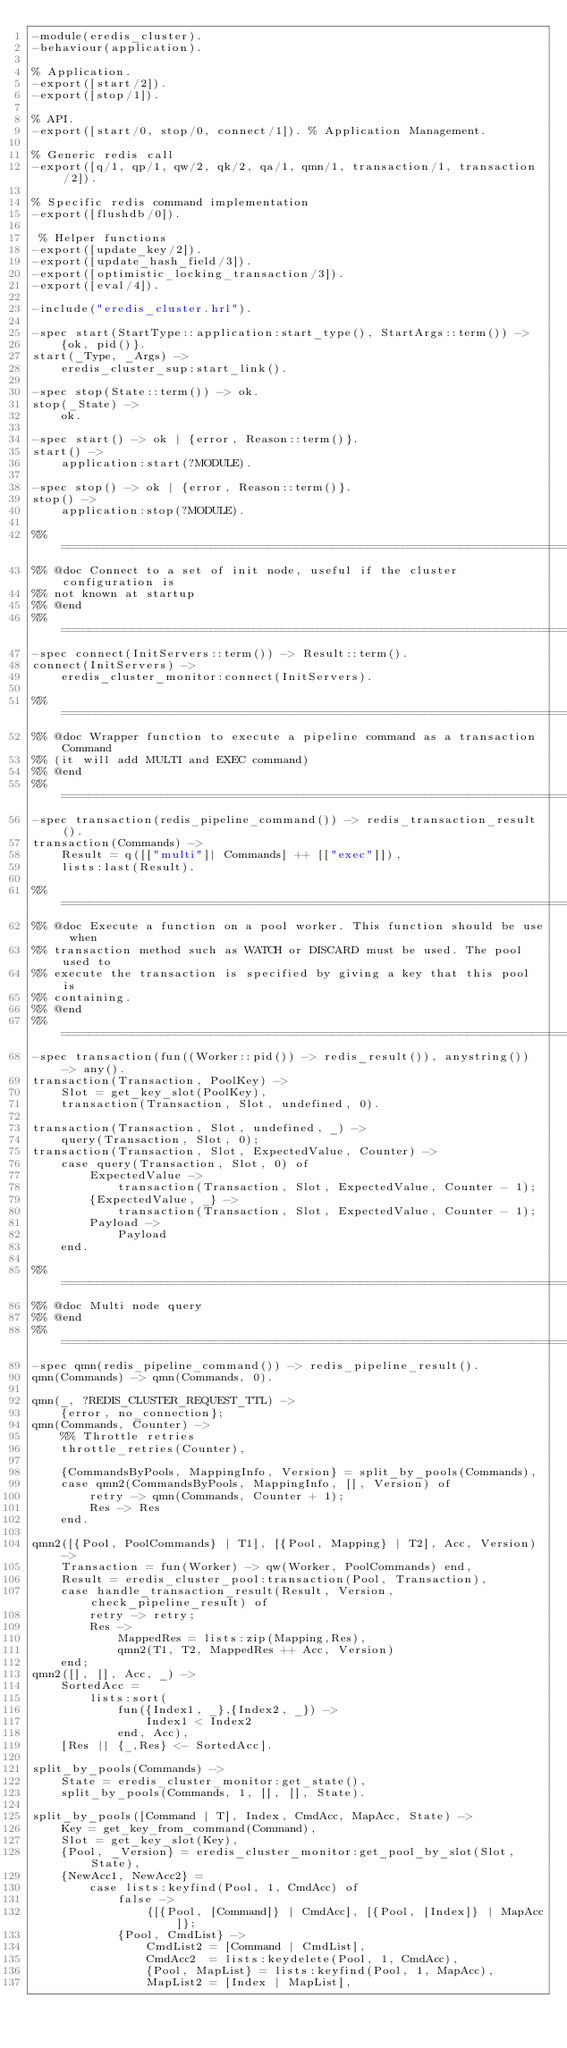<code> <loc_0><loc_0><loc_500><loc_500><_Erlang_>-module(eredis_cluster).
-behaviour(application).

% Application.
-export([start/2]).
-export([stop/1]).

% API.
-export([start/0, stop/0, connect/1]). % Application Management.

% Generic redis call
-export([q/1, qp/1, qw/2, qk/2, qa/1, qmn/1, transaction/1, transaction/2]).

% Specific redis command implementation
-export([flushdb/0]).

 % Helper functions
-export([update_key/2]).
-export([update_hash_field/3]).
-export([optimistic_locking_transaction/3]).
-export([eval/4]).

-include("eredis_cluster.hrl").

-spec start(StartType::application:start_type(), StartArgs::term()) ->
    {ok, pid()}.
start(_Type, _Args) ->
    eredis_cluster_sup:start_link().

-spec stop(State::term()) -> ok.
stop(_State) ->
    ok.

-spec start() -> ok | {error, Reason::term()}.
start() ->
    application:start(?MODULE).

-spec stop() -> ok | {error, Reason::term()}.
stop() ->
    application:stop(?MODULE).

%% =============================================================================
%% @doc Connect to a set of init node, useful if the cluster configuration is
%% not known at startup
%% @end
%% =============================================================================
-spec connect(InitServers::term()) -> Result::term().
connect(InitServers) ->
    eredis_cluster_monitor:connect(InitServers).

%% =============================================================================
%% @doc Wrapper function to execute a pipeline command as a transaction Command
%% (it will add MULTI and EXEC command)
%% @end
%% =============================================================================
-spec transaction(redis_pipeline_command()) -> redis_transaction_result().
transaction(Commands) ->
    Result = q([["multi"]| Commands] ++ [["exec"]]),
    lists:last(Result).

%% =============================================================================
%% @doc Execute a function on a pool worker. This function should be use when
%% transaction method such as WATCH or DISCARD must be used. The pool used to
%% execute the transaction is specified by giving a key that this pool is
%% containing.
%% @end
%% =============================================================================
-spec transaction(fun((Worker::pid()) -> redis_result()), anystring()) -> any().
transaction(Transaction, PoolKey) ->
    Slot = get_key_slot(PoolKey),
    transaction(Transaction, Slot, undefined, 0).

transaction(Transaction, Slot, undefined, _) ->
    query(Transaction, Slot, 0);
transaction(Transaction, Slot, ExpectedValue, Counter) ->
    case query(Transaction, Slot, 0) of
        ExpectedValue ->
            transaction(Transaction, Slot, ExpectedValue, Counter - 1);
        {ExpectedValue, _} ->
            transaction(Transaction, Slot, ExpectedValue, Counter - 1);
        Payload ->
            Payload
    end.

%% =============================================================================
%% @doc Multi node query
%% @end
%% =============================================================================
-spec qmn(redis_pipeline_command()) -> redis_pipeline_result().
qmn(Commands) -> qmn(Commands, 0).

qmn(_, ?REDIS_CLUSTER_REQUEST_TTL) -> 
    {error, no_connection};
qmn(Commands, Counter) ->
    %% Throttle retries
    throttle_retries(Counter),

    {CommandsByPools, MappingInfo, Version} = split_by_pools(Commands),
    case qmn2(CommandsByPools, MappingInfo, [], Version) of
        retry -> qmn(Commands, Counter + 1);
        Res -> Res
    end.

qmn2([{Pool, PoolCommands} | T1], [{Pool, Mapping} | T2], Acc, Version) ->
    Transaction = fun(Worker) -> qw(Worker, PoolCommands) end,
    Result = eredis_cluster_pool:transaction(Pool, Transaction),
    case handle_transaction_result(Result, Version, check_pipeline_result) of
        retry -> retry;
        Res -> 
            MappedRes = lists:zip(Mapping,Res),
            qmn2(T1, T2, MappedRes ++ Acc, Version)
    end;
qmn2([], [], Acc, _) ->
    SortedAcc =
        lists:sort(
            fun({Index1, _},{Index2, _}) ->
                Index1 < Index2
            end, Acc),
    [Res || {_,Res} <- SortedAcc].

split_by_pools(Commands) ->
    State = eredis_cluster_monitor:get_state(),
    split_by_pools(Commands, 1, [], [], State).

split_by_pools([Command | T], Index, CmdAcc, MapAcc, State) ->
    Key = get_key_from_command(Command),
    Slot = get_key_slot(Key),
    {Pool, _Version} = eredis_cluster_monitor:get_pool_by_slot(Slot, State),
    {NewAcc1, NewAcc2} =
        case lists:keyfind(Pool, 1, CmdAcc) of
            false ->
                {[{Pool, [Command]} | CmdAcc], [{Pool, [Index]} | MapAcc]};
            {Pool, CmdList} ->
                CmdList2 = [Command | CmdList],
                CmdAcc2  = lists:keydelete(Pool, 1, CmdAcc),
                {Pool, MapList} = lists:keyfind(Pool, 1, MapAcc),
                MapList2 = [Index | MapList],</code> 